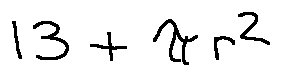Convert formula to latex. <formula><loc_0><loc_0><loc_500><loc_500>1 3 + \pi r ^ { 2 }</formula> 